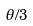<formula> <loc_0><loc_0><loc_500><loc_500>\theta / 3</formula> 